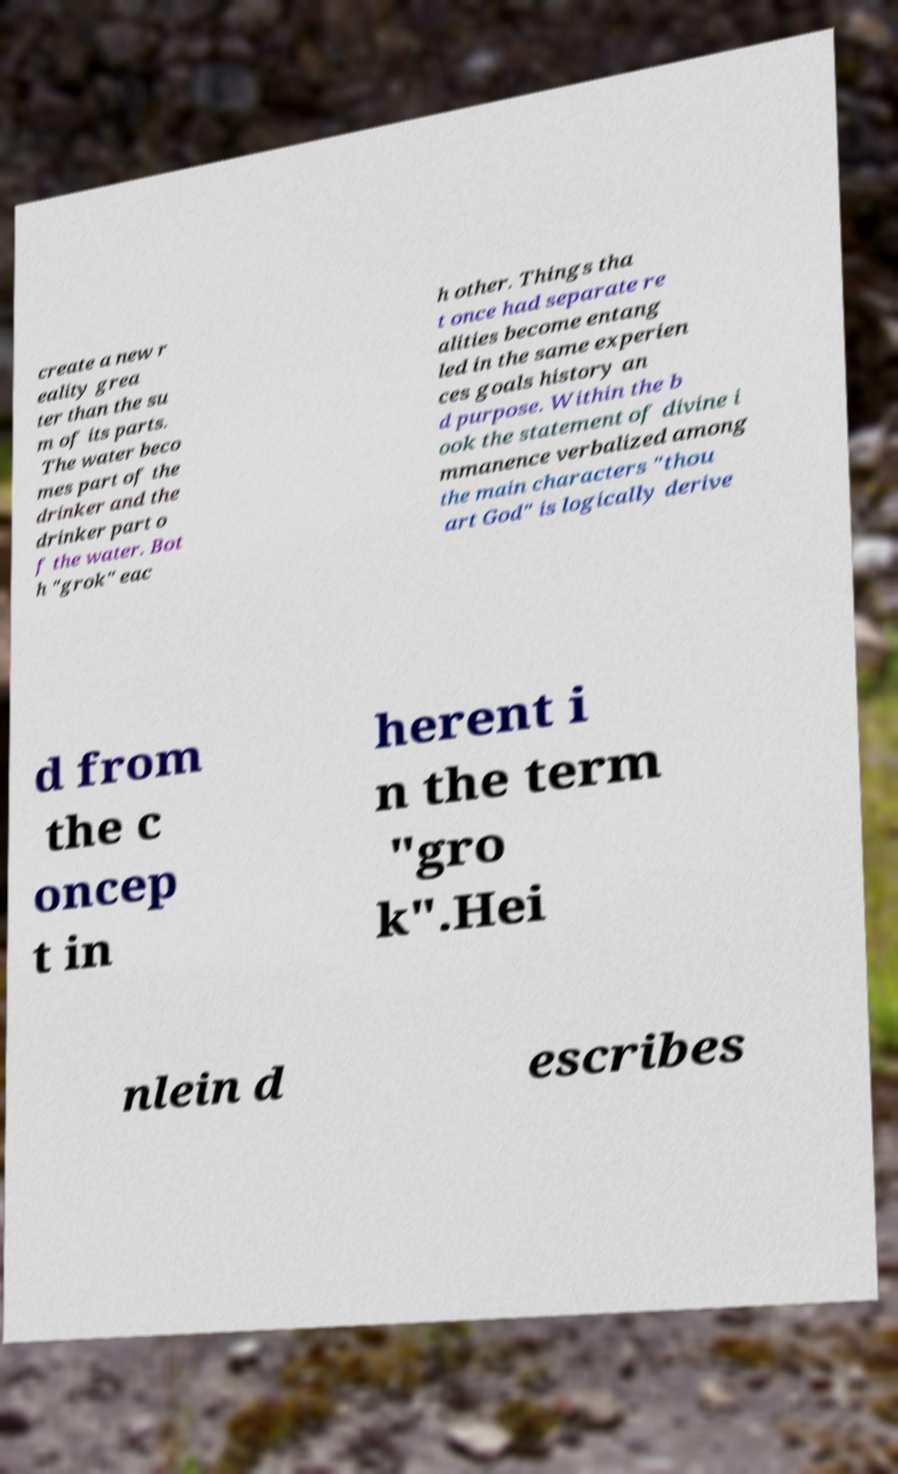I need the written content from this picture converted into text. Can you do that? create a new r eality grea ter than the su m of its parts. The water beco mes part of the drinker and the drinker part o f the water. Bot h "grok" eac h other. Things tha t once had separate re alities become entang led in the same experien ces goals history an d purpose. Within the b ook the statement of divine i mmanence verbalized among the main characters "thou art God" is logically derive d from the c oncep t in herent i n the term "gro k".Hei nlein d escribes 